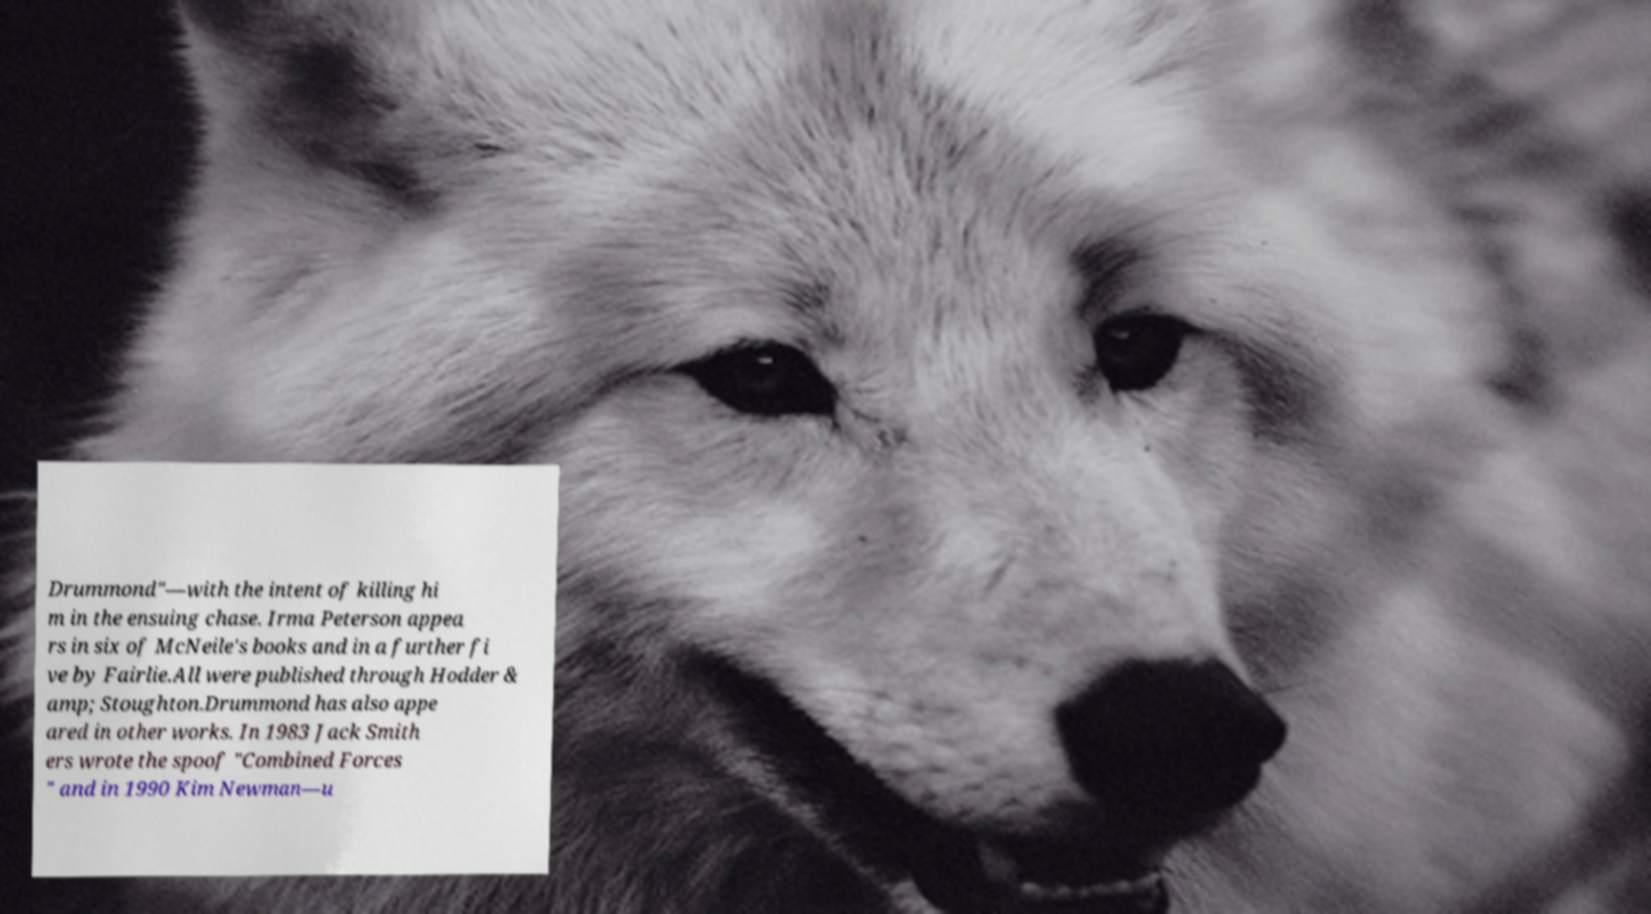Can you read and provide the text displayed in the image?This photo seems to have some interesting text. Can you extract and type it out for me? Drummond"—with the intent of killing hi m in the ensuing chase. Irma Peterson appea rs in six of McNeile's books and in a further fi ve by Fairlie.All were published through Hodder & amp; Stoughton.Drummond has also appe ared in other works. In 1983 Jack Smith ers wrote the spoof "Combined Forces " and in 1990 Kim Newman—u 